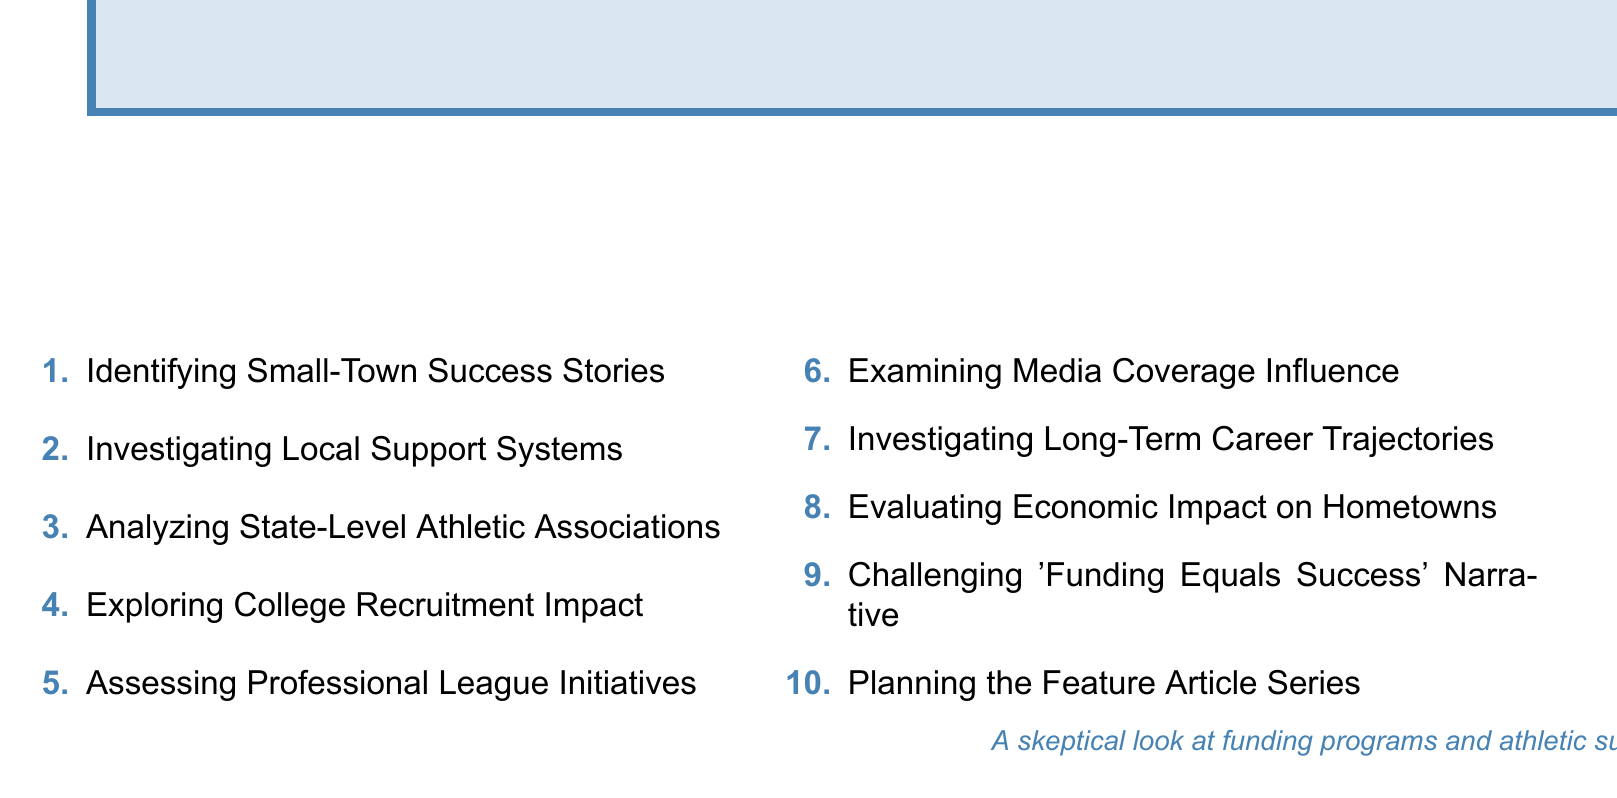What is the focus of the first agenda topic? The first agenda topic is about identifying small-town athletes who have achieved success.
Answer: Identifying Small-Town Success Stories How many subtopics are under "Investigating Local Support Systems"? There are four subtopics mentioned under this agenda topic.
Answer: 4 What is one example used in the agenda for local support systems? The agenda specifically mentions Joe Burrow's impact on Athens, Ohio.
Answer: Joe Burrow Which professional leagues are focused on in the agenda? The agenda covers athletes from NFL, NBA, MLB, and NHL.
Answer: NFL, NBA, MLB, NHL What role does the last agenda topic have in the discussion? The last agenda topic challenges the common narrative that funding is directly related to athletic success.
Answer: Challenging the 'Funding Equals Success' Narrative Which town is highlighted in the case study of the second agenda topic? The case study in the second agenda topic focuses on Athens, Ohio.
Answer: Athens, Ohio How many main agenda topics are listed in total? There are ten main topics outlined in the document.
Answer: 10 What is the intended perspective of the planning session as stated in the document? The document conveys a skeptical look at funding programs and their effectiveness.
Answer: A skeptical look at funding programs and athletic success 